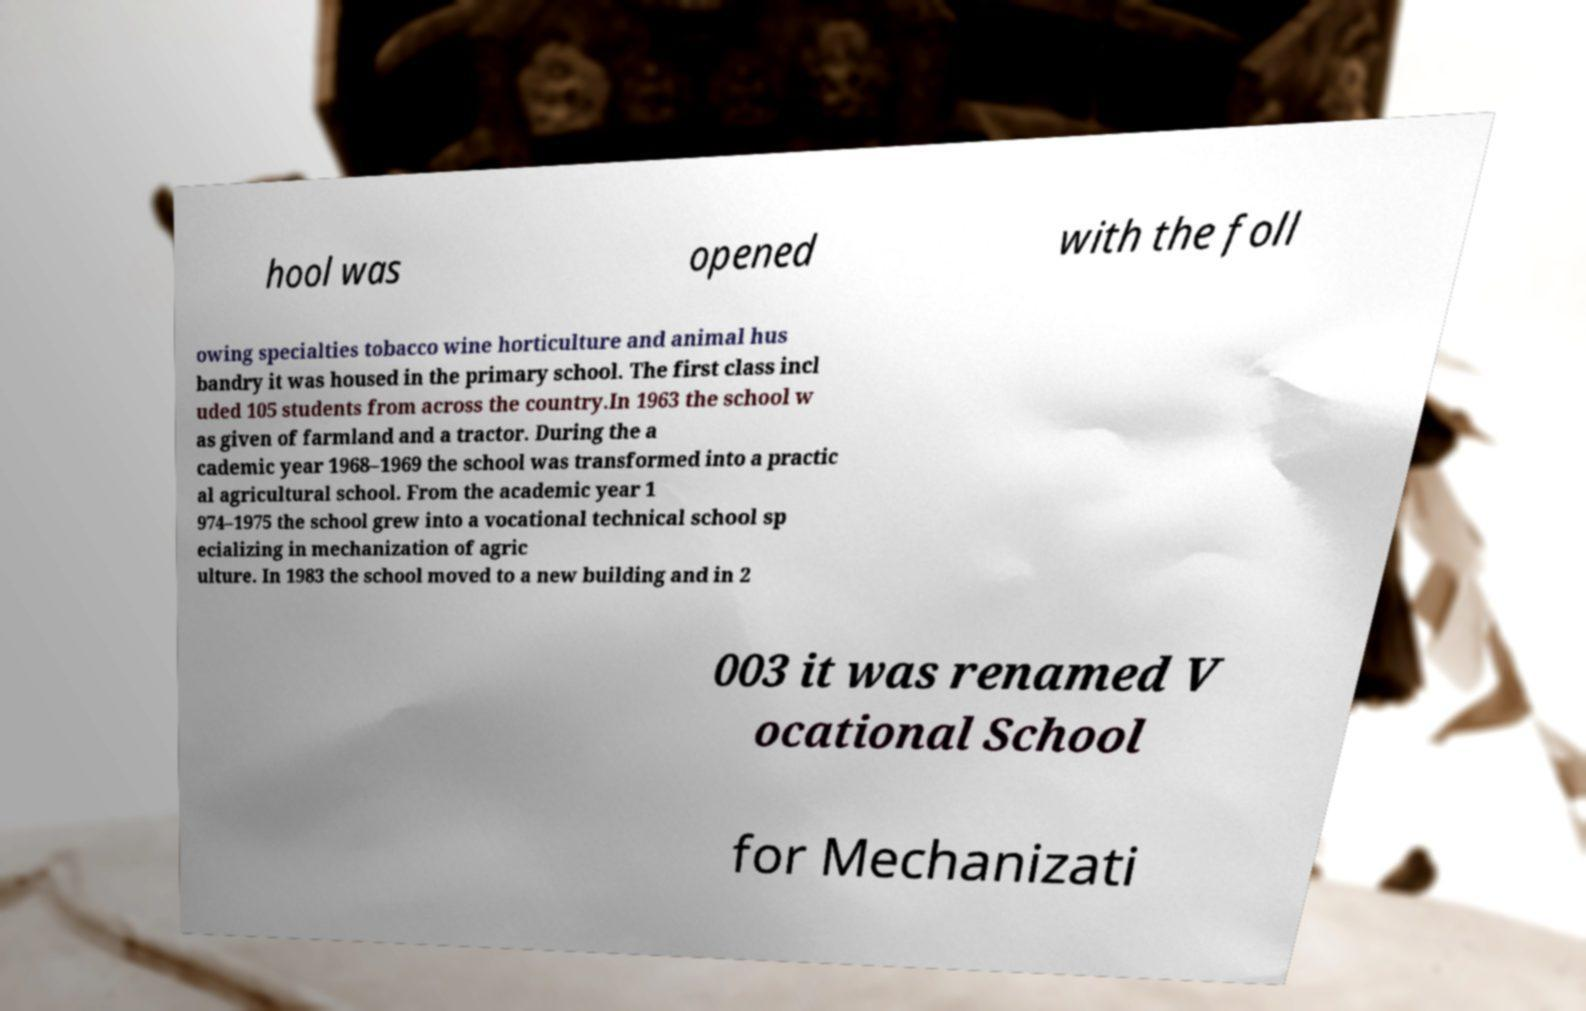Please read and relay the text visible in this image. What does it say? hool was opened with the foll owing specialties tobacco wine horticulture and animal hus bandry it was housed in the primary school. The first class incl uded 105 students from across the country.In 1963 the school w as given of farmland and a tractor. During the a cademic year 1968–1969 the school was transformed into a practic al agricultural school. From the academic year 1 974–1975 the school grew into a vocational technical school sp ecializing in mechanization of agric ulture. In 1983 the school moved to a new building and in 2 003 it was renamed V ocational School for Mechanizati 